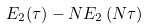<formula> <loc_0><loc_0><loc_500><loc_500>E _ { 2 } ( \tau ) - { N } E _ { 2 } \left ( N \tau \right )</formula> 